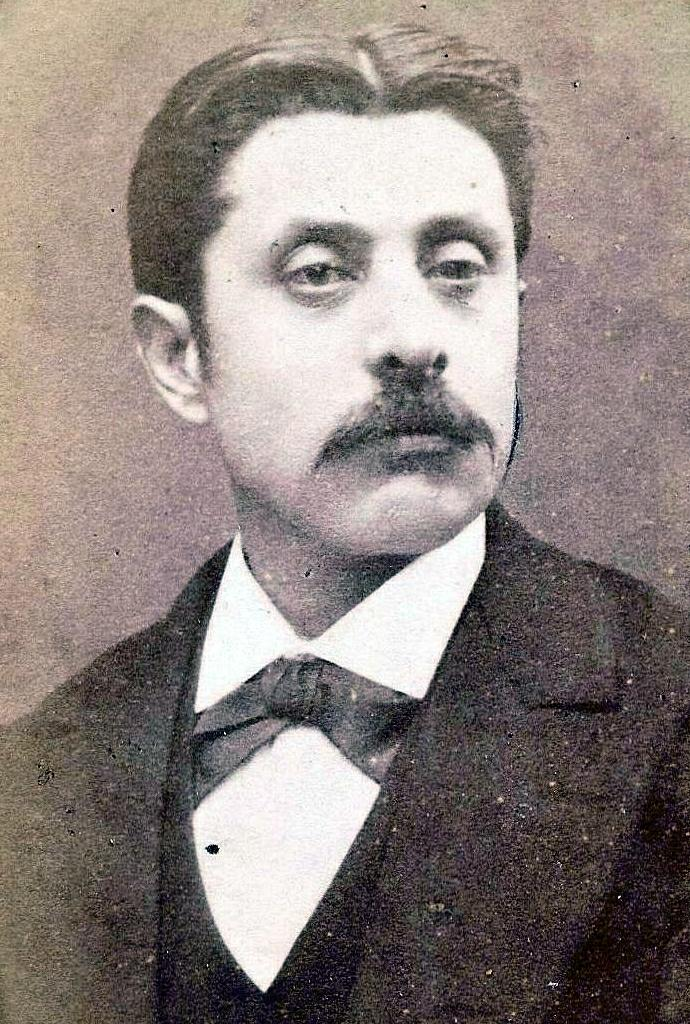What is the main subject of the image? The main subject of the image is a man. What is the man wearing in the image? The man is wearing a suit in the image. What type of wool can be seen on the deer in the image? There is no deer present in the image, and therefore no wool can be observed. What kind of marble is visible on the floor in the image? There is no marble floor visible in the image. 